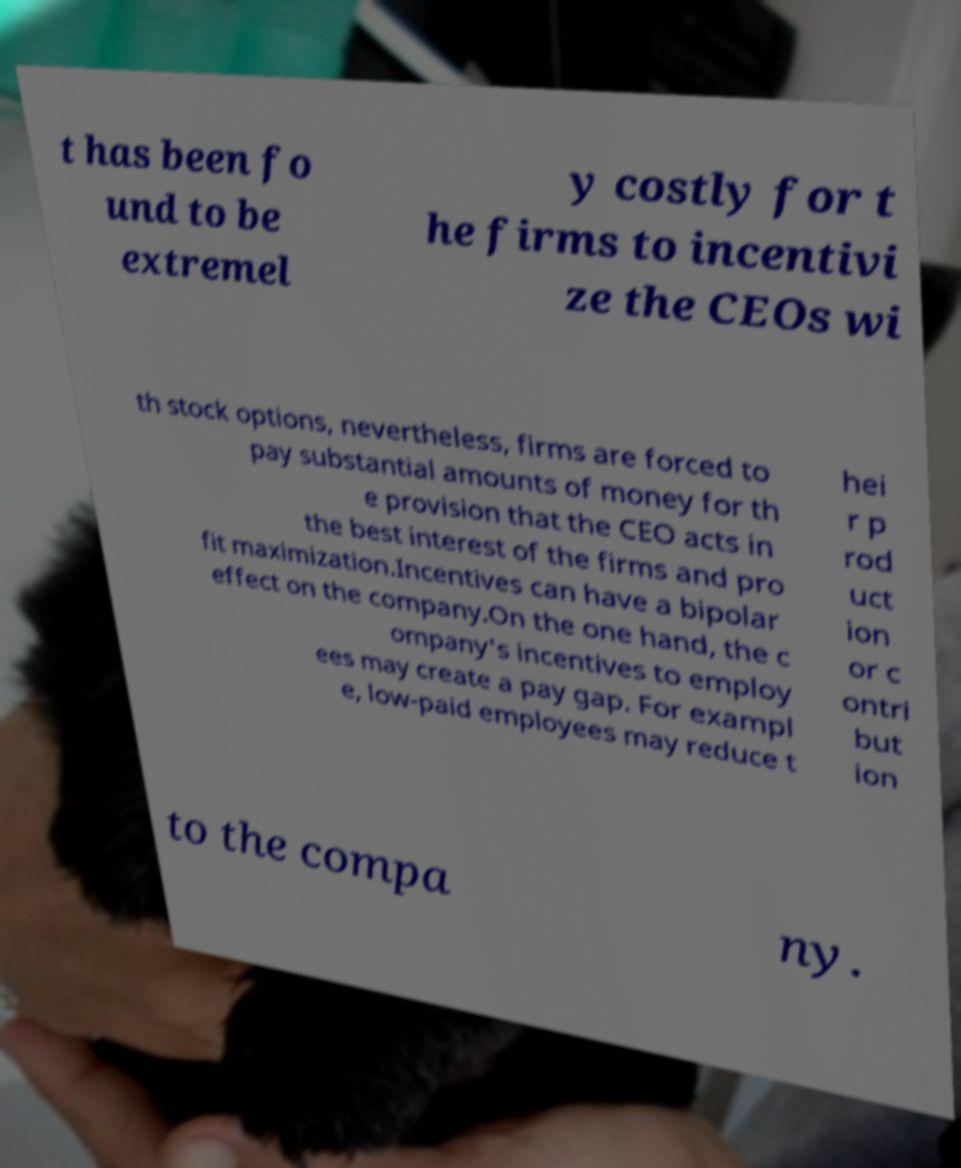Can you accurately transcribe the text from the provided image for me? t has been fo und to be extremel y costly for t he firms to incentivi ze the CEOs wi th stock options, nevertheless, firms are forced to pay substantial amounts of money for th e provision that the CEO acts in the best interest of the firms and pro fit maximization.Incentives can have a bipolar effect on the company.On the one hand, the c ompany's incentives to employ ees may create a pay gap. For exampl e, low-paid employees may reduce t hei r p rod uct ion or c ontri but ion to the compa ny. 